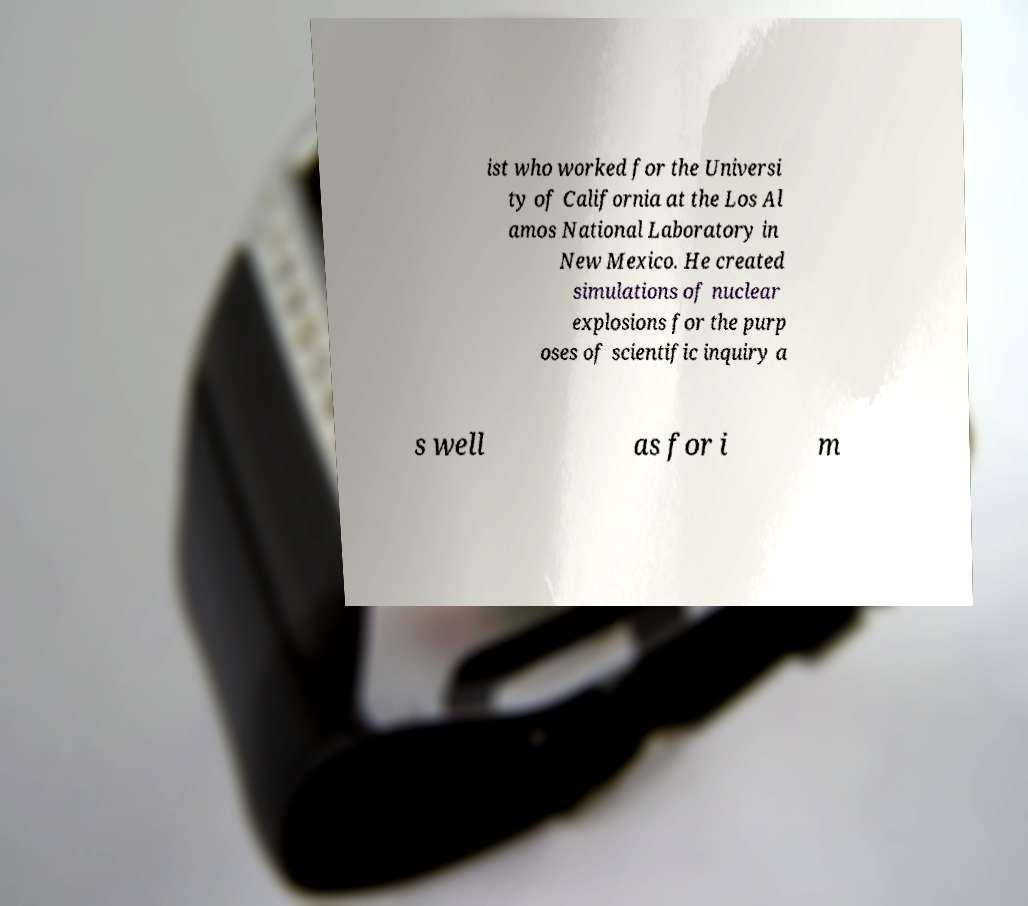Can you accurately transcribe the text from the provided image for me? ist who worked for the Universi ty of California at the Los Al amos National Laboratory in New Mexico. He created simulations of nuclear explosions for the purp oses of scientific inquiry a s well as for i m 